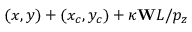Convert formula to latex. <formula><loc_0><loc_0><loc_500><loc_500>( x , y ) + ( x _ { c } , y _ { c } ) + \kappa W L / p _ { z }</formula> 